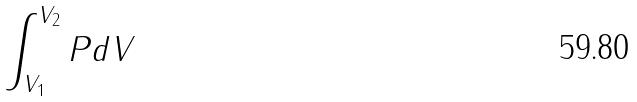<formula> <loc_0><loc_0><loc_500><loc_500>\int _ { V _ { 1 } } ^ { V _ { 2 } } P d V</formula> 